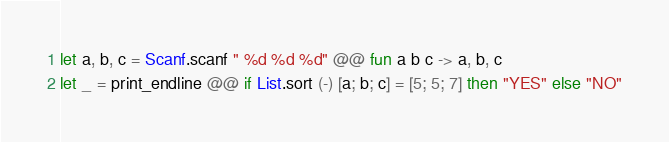<code> <loc_0><loc_0><loc_500><loc_500><_OCaml_>let a, b, c = Scanf.scanf " %d %d %d" @@ fun a b c -> a, b, c
let _ = print_endline @@ if List.sort (-) [a; b; c] = [5; 5; 7] then "YES" else "NO"</code> 